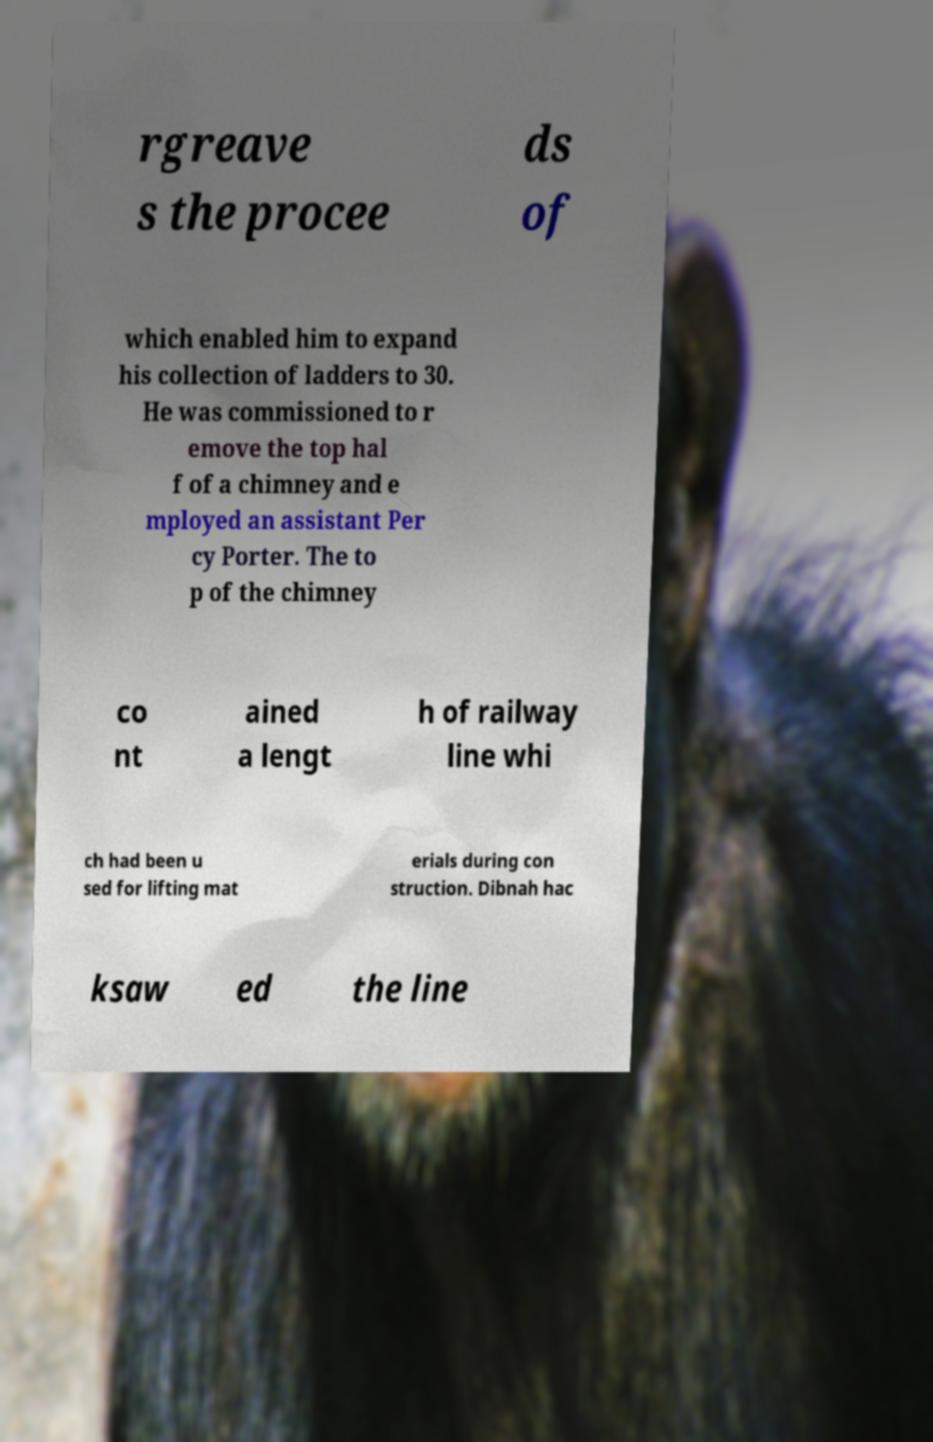I need the written content from this picture converted into text. Can you do that? rgreave s the procee ds of which enabled him to expand his collection of ladders to 30. He was commissioned to r emove the top hal f of a chimney and e mployed an assistant Per cy Porter. The to p of the chimney co nt ained a lengt h of railway line whi ch had been u sed for lifting mat erials during con struction. Dibnah hac ksaw ed the line 